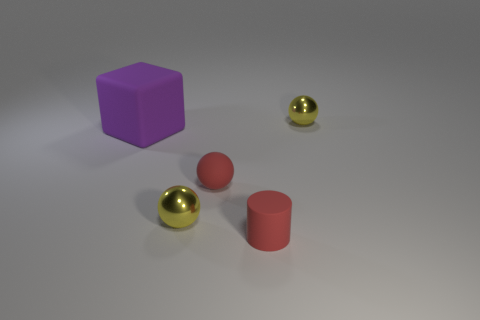There is a small object that is both in front of the rubber block and on the right side of the tiny red rubber sphere; what is its color?
Your answer should be very brief. Red. What number of big matte things are there?
Keep it short and to the point. 1. Are the cube and the cylinder made of the same material?
Your response must be concise. Yes. The metallic object that is in front of the yellow object behind the big purple object that is behind the small cylinder is what shape?
Give a very brief answer. Sphere. Are the yellow sphere in front of the large cube and the red thing that is behind the red cylinder made of the same material?
Provide a succinct answer. No. What material is the large purple block?
Provide a succinct answer. Rubber. What number of other purple objects are the same shape as the large object?
Offer a terse response. 0. There is a cylinder that is the same color as the small rubber ball; what is it made of?
Give a very brief answer. Rubber. Is there anything else that has the same shape as the large purple thing?
Your answer should be very brief. No. There is a small metallic sphere in front of the yellow ball that is to the right of the small cylinder that is right of the matte block; what color is it?
Keep it short and to the point. Yellow. 